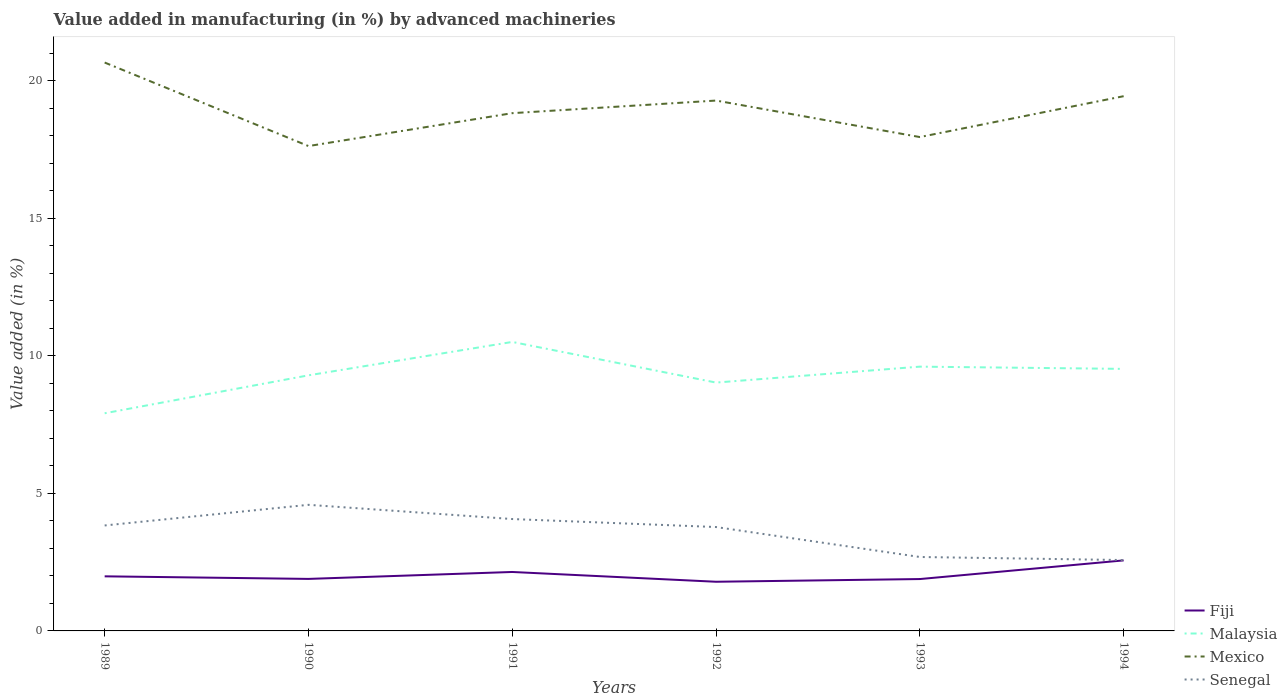Is the number of lines equal to the number of legend labels?
Your response must be concise. Yes. Across all years, what is the maximum percentage of value added in manufacturing by advanced machineries in Senegal?
Provide a succinct answer. 2.58. In which year was the percentage of value added in manufacturing by advanced machineries in Malaysia maximum?
Offer a very short reply. 1989. What is the total percentage of value added in manufacturing by advanced machineries in Senegal in the graph?
Offer a very short reply. 1.2. What is the difference between the highest and the second highest percentage of value added in manufacturing by advanced machineries in Senegal?
Give a very brief answer. 2.01. How many lines are there?
Ensure brevity in your answer.  4. How many years are there in the graph?
Make the answer very short. 6. What is the difference between two consecutive major ticks on the Y-axis?
Provide a short and direct response. 5. Does the graph contain grids?
Make the answer very short. No. Where does the legend appear in the graph?
Ensure brevity in your answer.  Bottom right. What is the title of the graph?
Offer a terse response. Value added in manufacturing (in %) by advanced machineries. Does "St. Vincent and the Grenadines" appear as one of the legend labels in the graph?
Your answer should be very brief. No. What is the label or title of the X-axis?
Keep it short and to the point. Years. What is the label or title of the Y-axis?
Give a very brief answer. Value added (in %). What is the Value added (in %) in Fiji in 1989?
Provide a short and direct response. 1.98. What is the Value added (in %) of Malaysia in 1989?
Provide a short and direct response. 7.91. What is the Value added (in %) of Mexico in 1989?
Your answer should be very brief. 20.66. What is the Value added (in %) in Senegal in 1989?
Your answer should be compact. 3.83. What is the Value added (in %) of Fiji in 1990?
Offer a very short reply. 1.89. What is the Value added (in %) of Malaysia in 1990?
Provide a succinct answer. 9.29. What is the Value added (in %) in Mexico in 1990?
Offer a very short reply. 17.62. What is the Value added (in %) of Senegal in 1990?
Keep it short and to the point. 4.58. What is the Value added (in %) in Fiji in 1991?
Provide a short and direct response. 2.14. What is the Value added (in %) in Malaysia in 1991?
Your response must be concise. 10.5. What is the Value added (in %) of Mexico in 1991?
Your answer should be very brief. 18.82. What is the Value added (in %) of Senegal in 1991?
Offer a terse response. 4.07. What is the Value added (in %) in Fiji in 1992?
Your answer should be compact. 1.79. What is the Value added (in %) in Malaysia in 1992?
Give a very brief answer. 9.03. What is the Value added (in %) of Mexico in 1992?
Offer a very short reply. 19.28. What is the Value added (in %) of Senegal in 1992?
Provide a short and direct response. 3.78. What is the Value added (in %) in Fiji in 1993?
Provide a succinct answer. 1.89. What is the Value added (in %) in Malaysia in 1993?
Ensure brevity in your answer.  9.6. What is the Value added (in %) in Mexico in 1993?
Give a very brief answer. 17.95. What is the Value added (in %) of Senegal in 1993?
Give a very brief answer. 2.69. What is the Value added (in %) in Fiji in 1994?
Provide a short and direct response. 2.56. What is the Value added (in %) in Malaysia in 1994?
Your answer should be very brief. 9.52. What is the Value added (in %) of Mexico in 1994?
Your response must be concise. 19.43. What is the Value added (in %) in Senegal in 1994?
Provide a succinct answer. 2.58. Across all years, what is the maximum Value added (in %) of Fiji?
Offer a terse response. 2.56. Across all years, what is the maximum Value added (in %) in Malaysia?
Offer a very short reply. 10.5. Across all years, what is the maximum Value added (in %) in Mexico?
Provide a short and direct response. 20.66. Across all years, what is the maximum Value added (in %) of Senegal?
Ensure brevity in your answer.  4.58. Across all years, what is the minimum Value added (in %) of Fiji?
Your response must be concise. 1.79. Across all years, what is the minimum Value added (in %) of Malaysia?
Ensure brevity in your answer.  7.91. Across all years, what is the minimum Value added (in %) of Mexico?
Your answer should be very brief. 17.62. Across all years, what is the minimum Value added (in %) in Senegal?
Ensure brevity in your answer.  2.58. What is the total Value added (in %) in Fiji in the graph?
Give a very brief answer. 12.25. What is the total Value added (in %) of Malaysia in the graph?
Give a very brief answer. 55.86. What is the total Value added (in %) of Mexico in the graph?
Offer a terse response. 113.75. What is the total Value added (in %) of Senegal in the graph?
Your answer should be very brief. 21.52. What is the difference between the Value added (in %) of Fiji in 1989 and that in 1990?
Ensure brevity in your answer.  0.09. What is the difference between the Value added (in %) of Malaysia in 1989 and that in 1990?
Offer a very short reply. -1.38. What is the difference between the Value added (in %) of Mexico in 1989 and that in 1990?
Offer a very short reply. 3.04. What is the difference between the Value added (in %) of Senegal in 1989 and that in 1990?
Offer a terse response. -0.75. What is the difference between the Value added (in %) in Fiji in 1989 and that in 1991?
Your response must be concise. -0.16. What is the difference between the Value added (in %) of Malaysia in 1989 and that in 1991?
Offer a very short reply. -2.59. What is the difference between the Value added (in %) in Mexico in 1989 and that in 1991?
Make the answer very short. 1.84. What is the difference between the Value added (in %) in Senegal in 1989 and that in 1991?
Your response must be concise. -0.23. What is the difference between the Value added (in %) of Fiji in 1989 and that in 1992?
Offer a terse response. 0.2. What is the difference between the Value added (in %) in Malaysia in 1989 and that in 1992?
Keep it short and to the point. -1.12. What is the difference between the Value added (in %) in Mexico in 1989 and that in 1992?
Make the answer very short. 1.38. What is the difference between the Value added (in %) of Senegal in 1989 and that in 1992?
Keep it short and to the point. 0.06. What is the difference between the Value added (in %) of Fiji in 1989 and that in 1993?
Make the answer very short. 0.1. What is the difference between the Value added (in %) of Malaysia in 1989 and that in 1993?
Your response must be concise. -1.69. What is the difference between the Value added (in %) of Mexico in 1989 and that in 1993?
Offer a very short reply. 2.71. What is the difference between the Value added (in %) of Senegal in 1989 and that in 1993?
Provide a short and direct response. 1.15. What is the difference between the Value added (in %) of Fiji in 1989 and that in 1994?
Ensure brevity in your answer.  -0.58. What is the difference between the Value added (in %) of Malaysia in 1989 and that in 1994?
Provide a short and direct response. -1.61. What is the difference between the Value added (in %) of Mexico in 1989 and that in 1994?
Provide a short and direct response. 1.22. What is the difference between the Value added (in %) of Senegal in 1989 and that in 1994?
Your answer should be very brief. 1.26. What is the difference between the Value added (in %) of Fiji in 1990 and that in 1991?
Offer a very short reply. -0.25. What is the difference between the Value added (in %) in Malaysia in 1990 and that in 1991?
Make the answer very short. -1.21. What is the difference between the Value added (in %) of Mexico in 1990 and that in 1991?
Your response must be concise. -1.2. What is the difference between the Value added (in %) of Senegal in 1990 and that in 1991?
Ensure brevity in your answer.  0.52. What is the difference between the Value added (in %) of Fiji in 1990 and that in 1992?
Offer a terse response. 0.1. What is the difference between the Value added (in %) of Malaysia in 1990 and that in 1992?
Make the answer very short. 0.26. What is the difference between the Value added (in %) in Mexico in 1990 and that in 1992?
Keep it short and to the point. -1.65. What is the difference between the Value added (in %) in Senegal in 1990 and that in 1992?
Your answer should be very brief. 0.81. What is the difference between the Value added (in %) in Fiji in 1990 and that in 1993?
Make the answer very short. 0.01. What is the difference between the Value added (in %) in Malaysia in 1990 and that in 1993?
Keep it short and to the point. -0.32. What is the difference between the Value added (in %) in Mexico in 1990 and that in 1993?
Your answer should be compact. -0.33. What is the difference between the Value added (in %) in Senegal in 1990 and that in 1993?
Your response must be concise. 1.9. What is the difference between the Value added (in %) of Fiji in 1990 and that in 1994?
Offer a terse response. -0.67. What is the difference between the Value added (in %) of Malaysia in 1990 and that in 1994?
Ensure brevity in your answer.  -0.23. What is the difference between the Value added (in %) of Mexico in 1990 and that in 1994?
Make the answer very short. -1.81. What is the difference between the Value added (in %) of Senegal in 1990 and that in 1994?
Your response must be concise. 2.01. What is the difference between the Value added (in %) in Fiji in 1991 and that in 1992?
Provide a short and direct response. 0.36. What is the difference between the Value added (in %) in Malaysia in 1991 and that in 1992?
Provide a short and direct response. 1.48. What is the difference between the Value added (in %) of Mexico in 1991 and that in 1992?
Your answer should be very brief. -0.46. What is the difference between the Value added (in %) of Senegal in 1991 and that in 1992?
Your answer should be very brief. 0.29. What is the difference between the Value added (in %) in Fiji in 1991 and that in 1993?
Your answer should be compact. 0.26. What is the difference between the Value added (in %) in Malaysia in 1991 and that in 1993?
Your response must be concise. 0.9. What is the difference between the Value added (in %) of Mexico in 1991 and that in 1993?
Provide a short and direct response. 0.87. What is the difference between the Value added (in %) in Senegal in 1991 and that in 1993?
Keep it short and to the point. 1.38. What is the difference between the Value added (in %) in Fiji in 1991 and that in 1994?
Offer a terse response. -0.42. What is the difference between the Value added (in %) of Malaysia in 1991 and that in 1994?
Ensure brevity in your answer.  0.98. What is the difference between the Value added (in %) of Mexico in 1991 and that in 1994?
Make the answer very short. -0.62. What is the difference between the Value added (in %) in Senegal in 1991 and that in 1994?
Keep it short and to the point. 1.49. What is the difference between the Value added (in %) of Fiji in 1992 and that in 1993?
Offer a very short reply. -0.1. What is the difference between the Value added (in %) of Malaysia in 1992 and that in 1993?
Ensure brevity in your answer.  -0.58. What is the difference between the Value added (in %) of Mexico in 1992 and that in 1993?
Give a very brief answer. 1.33. What is the difference between the Value added (in %) of Senegal in 1992 and that in 1993?
Your answer should be very brief. 1.09. What is the difference between the Value added (in %) in Fiji in 1992 and that in 1994?
Offer a terse response. -0.78. What is the difference between the Value added (in %) of Malaysia in 1992 and that in 1994?
Make the answer very short. -0.5. What is the difference between the Value added (in %) of Mexico in 1992 and that in 1994?
Keep it short and to the point. -0.16. What is the difference between the Value added (in %) in Senegal in 1992 and that in 1994?
Your response must be concise. 1.2. What is the difference between the Value added (in %) in Fiji in 1993 and that in 1994?
Ensure brevity in your answer.  -0.68. What is the difference between the Value added (in %) of Malaysia in 1993 and that in 1994?
Your answer should be compact. 0.08. What is the difference between the Value added (in %) in Mexico in 1993 and that in 1994?
Keep it short and to the point. -1.49. What is the difference between the Value added (in %) of Senegal in 1993 and that in 1994?
Give a very brief answer. 0.11. What is the difference between the Value added (in %) in Fiji in 1989 and the Value added (in %) in Malaysia in 1990?
Make the answer very short. -7.3. What is the difference between the Value added (in %) in Fiji in 1989 and the Value added (in %) in Mexico in 1990?
Offer a terse response. -15.64. What is the difference between the Value added (in %) of Fiji in 1989 and the Value added (in %) of Senegal in 1990?
Give a very brief answer. -2.6. What is the difference between the Value added (in %) of Malaysia in 1989 and the Value added (in %) of Mexico in 1990?
Give a very brief answer. -9.71. What is the difference between the Value added (in %) of Malaysia in 1989 and the Value added (in %) of Senegal in 1990?
Give a very brief answer. 3.33. What is the difference between the Value added (in %) of Mexico in 1989 and the Value added (in %) of Senegal in 1990?
Give a very brief answer. 16.07. What is the difference between the Value added (in %) of Fiji in 1989 and the Value added (in %) of Malaysia in 1991?
Your answer should be very brief. -8.52. What is the difference between the Value added (in %) of Fiji in 1989 and the Value added (in %) of Mexico in 1991?
Your answer should be very brief. -16.83. What is the difference between the Value added (in %) in Fiji in 1989 and the Value added (in %) in Senegal in 1991?
Provide a short and direct response. -2.08. What is the difference between the Value added (in %) in Malaysia in 1989 and the Value added (in %) in Mexico in 1991?
Keep it short and to the point. -10.91. What is the difference between the Value added (in %) in Malaysia in 1989 and the Value added (in %) in Senegal in 1991?
Your answer should be compact. 3.84. What is the difference between the Value added (in %) in Mexico in 1989 and the Value added (in %) in Senegal in 1991?
Provide a succinct answer. 16.59. What is the difference between the Value added (in %) in Fiji in 1989 and the Value added (in %) in Malaysia in 1992?
Offer a very short reply. -7.04. What is the difference between the Value added (in %) of Fiji in 1989 and the Value added (in %) of Mexico in 1992?
Your answer should be compact. -17.29. What is the difference between the Value added (in %) of Fiji in 1989 and the Value added (in %) of Senegal in 1992?
Offer a very short reply. -1.79. What is the difference between the Value added (in %) in Malaysia in 1989 and the Value added (in %) in Mexico in 1992?
Your answer should be very brief. -11.36. What is the difference between the Value added (in %) of Malaysia in 1989 and the Value added (in %) of Senegal in 1992?
Your answer should be compact. 4.14. What is the difference between the Value added (in %) of Mexico in 1989 and the Value added (in %) of Senegal in 1992?
Keep it short and to the point. 16.88. What is the difference between the Value added (in %) in Fiji in 1989 and the Value added (in %) in Malaysia in 1993?
Ensure brevity in your answer.  -7.62. What is the difference between the Value added (in %) of Fiji in 1989 and the Value added (in %) of Mexico in 1993?
Provide a short and direct response. -15.96. What is the difference between the Value added (in %) in Fiji in 1989 and the Value added (in %) in Senegal in 1993?
Give a very brief answer. -0.7. What is the difference between the Value added (in %) of Malaysia in 1989 and the Value added (in %) of Mexico in 1993?
Provide a succinct answer. -10.04. What is the difference between the Value added (in %) of Malaysia in 1989 and the Value added (in %) of Senegal in 1993?
Provide a succinct answer. 5.22. What is the difference between the Value added (in %) in Mexico in 1989 and the Value added (in %) in Senegal in 1993?
Offer a very short reply. 17.97. What is the difference between the Value added (in %) in Fiji in 1989 and the Value added (in %) in Malaysia in 1994?
Your response must be concise. -7.54. What is the difference between the Value added (in %) in Fiji in 1989 and the Value added (in %) in Mexico in 1994?
Your answer should be compact. -17.45. What is the difference between the Value added (in %) in Fiji in 1989 and the Value added (in %) in Senegal in 1994?
Provide a short and direct response. -0.59. What is the difference between the Value added (in %) of Malaysia in 1989 and the Value added (in %) of Mexico in 1994?
Keep it short and to the point. -11.52. What is the difference between the Value added (in %) of Malaysia in 1989 and the Value added (in %) of Senegal in 1994?
Keep it short and to the point. 5.33. What is the difference between the Value added (in %) in Mexico in 1989 and the Value added (in %) in Senegal in 1994?
Make the answer very short. 18.08. What is the difference between the Value added (in %) in Fiji in 1990 and the Value added (in %) in Malaysia in 1991?
Provide a short and direct response. -8.61. What is the difference between the Value added (in %) of Fiji in 1990 and the Value added (in %) of Mexico in 1991?
Give a very brief answer. -16.93. What is the difference between the Value added (in %) of Fiji in 1990 and the Value added (in %) of Senegal in 1991?
Your answer should be compact. -2.18. What is the difference between the Value added (in %) in Malaysia in 1990 and the Value added (in %) in Mexico in 1991?
Give a very brief answer. -9.53. What is the difference between the Value added (in %) of Malaysia in 1990 and the Value added (in %) of Senegal in 1991?
Make the answer very short. 5.22. What is the difference between the Value added (in %) of Mexico in 1990 and the Value added (in %) of Senegal in 1991?
Give a very brief answer. 13.56. What is the difference between the Value added (in %) of Fiji in 1990 and the Value added (in %) of Malaysia in 1992?
Give a very brief answer. -7.14. What is the difference between the Value added (in %) of Fiji in 1990 and the Value added (in %) of Mexico in 1992?
Your answer should be very brief. -17.38. What is the difference between the Value added (in %) of Fiji in 1990 and the Value added (in %) of Senegal in 1992?
Offer a terse response. -1.89. What is the difference between the Value added (in %) of Malaysia in 1990 and the Value added (in %) of Mexico in 1992?
Your response must be concise. -9.99. What is the difference between the Value added (in %) in Malaysia in 1990 and the Value added (in %) in Senegal in 1992?
Provide a succinct answer. 5.51. What is the difference between the Value added (in %) in Mexico in 1990 and the Value added (in %) in Senegal in 1992?
Give a very brief answer. 13.85. What is the difference between the Value added (in %) in Fiji in 1990 and the Value added (in %) in Malaysia in 1993?
Offer a very short reply. -7.71. What is the difference between the Value added (in %) in Fiji in 1990 and the Value added (in %) in Mexico in 1993?
Ensure brevity in your answer.  -16.06. What is the difference between the Value added (in %) in Fiji in 1990 and the Value added (in %) in Senegal in 1993?
Ensure brevity in your answer.  -0.8. What is the difference between the Value added (in %) of Malaysia in 1990 and the Value added (in %) of Mexico in 1993?
Offer a very short reply. -8.66. What is the difference between the Value added (in %) in Malaysia in 1990 and the Value added (in %) in Senegal in 1993?
Ensure brevity in your answer.  6.6. What is the difference between the Value added (in %) of Mexico in 1990 and the Value added (in %) of Senegal in 1993?
Provide a succinct answer. 14.93. What is the difference between the Value added (in %) in Fiji in 1990 and the Value added (in %) in Malaysia in 1994?
Provide a succinct answer. -7.63. What is the difference between the Value added (in %) in Fiji in 1990 and the Value added (in %) in Mexico in 1994?
Ensure brevity in your answer.  -17.54. What is the difference between the Value added (in %) in Fiji in 1990 and the Value added (in %) in Senegal in 1994?
Ensure brevity in your answer.  -0.69. What is the difference between the Value added (in %) of Malaysia in 1990 and the Value added (in %) of Mexico in 1994?
Keep it short and to the point. -10.15. What is the difference between the Value added (in %) of Malaysia in 1990 and the Value added (in %) of Senegal in 1994?
Keep it short and to the point. 6.71. What is the difference between the Value added (in %) of Mexico in 1990 and the Value added (in %) of Senegal in 1994?
Give a very brief answer. 15.05. What is the difference between the Value added (in %) in Fiji in 1991 and the Value added (in %) in Malaysia in 1992?
Keep it short and to the point. -6.88. What is the difference between the Value added (in %) in Fiji in 1991 and the Value added (in %) in Mexico in 1992?
Ensure brevity in your answer.  -17.13. What is the difference between the Value added (in %) of Fiji in 1991 and the Value added (in %) of Senegal in 1992?
Make the answer very short. -1.63. What is the difference between the Value added (in %) in Malaysia in 1991 and the Value added (in %) in Mexico in 1992?
Provide a short and direct response. -8.77. What is the difference between the Value added (in %) of Malaysia in 1991 and the Value added (in %) of Senegal in 1992?
Your response must be concise. 6.73. What is the difference between the Value added (in %) of Mexico in 1991 and the Value added (in %) of Senegal in 1992?
Offer a terse response. 15.04. What is the difference between the Value added (in %) in Fiji in 1991 and the Value added (in %) in Malaysia in 1993?
Offer a very short reply. -7.46. What is the difference between the Value added (in %) in Fiji in 1991 and the Value added (in %) in Mexico in 1993?
Your answer should be compact. -15.81. What is the difference between the Value added (in %) in Fiji in 1991 and the Value added (in %) in Senegal in 1993?
Offer a terse response. -0.54. What is the difference between the Value added (in %) in Malaysia in 1991 and the Value added (in %) in Mexico in 1993?
Your answer should be very brief. -7.45. What is the difference between the Value added (in %) in Malaysia in 1991 and the Value added (in %) in Senegal in 1993?
Keep it short and to the point. 7.82. What is the difference between the Value added (in %) of Mexico in 1991 and the Value added (in %) of Senegal in 1993?
Your answer should be compact. 16.13. What is the difference between the Value added (in %) of Fiji in 1991 and the Value added (in %) of Malaysia in 1994?
Your answer should be compact. -7.38. What is the difference between the Value added (in %) in Fiji in 1991 and the Value added (in %) in Mexico in 1994?
Your response must be concise. -17.29. What is the difference between the Value added (in %) of Fiji in 1991 and the Value added (in %) of Senegal in 1994?
Your response must be concise. -0.43. What is the difference between the Value added (in %) in Malaysia in 1991 and the Value added (in %) in Mexico in 1994?
Give a very brief answer. -8.93. What is the difference between the Value added (in %) of Malaysia in 1991 and the Value added (in %) of Senegal in 1994?
Give a very brief answer. 7.93. What is the difference between the Value added (in %) of Mexico in 1991 and the Value added (in %) of Senegal in 1994?
Ensure brevity in your answer.  16.24. What is the difference between the Value added (in %) in Fiji in 1992 and the Value added (in %) in Malaysia in 1993?
Offer a terse response. -7.82. What is the difference between the Value added (in %) of Fiji in 1992 and the Value added (in %) of Mexico in 1993?
Make the answer very short. -16.16. What is the difference between the Value added (in %) of Fiji in 1992 and the Value added (in %) of Senegal in 1993?
Offer a terse response. -0.9. What is the difference between the Value added (in %) of Malaysia in 1992 and the Value added (in %) of Mexico in 1993?
Your answer should be very brief. -8.92. What is the difference between the Value added (in %) in Malaysia in 1992 and the Value added (in %) in Senegal in 1993?
Ensure brevity in your answer.  6.34. What is the difference between the Value added (in %) in Mexico in 1992 and the Value added (in %) in Senegal in 1993?
Make the answer very short. 16.59. What is the difference between the Value added (in %) of Fiji in 1992 and the Value added (in %) of Malaysia in 1994?
Make the answer very short. -7.74. What is the difference between the Value added (in %) in Fiji in 1992 and the Value added (in %) in Mexico in 1994?
Your answer should be compact. -17.65. What is the difference between the Value added (in %) of Fiji in 1992 and the Value added (in %) of Senegal in 1994?
Keep it short and to the point. -0.79. What is the difference between the Value added (in %) in Malaysia in 1992 and the Value added (in %) in Mexico in 1994?
Provide a short and direct response. -10.41. What is the difference between the Value added (in %) of Malaysia in 1992 and the Value added (in %) of Senegal in 1994?
Give a very brief answer. 6.45. What is the difference between the Value added (in %) of Mexico in 1992 and the Value added (in %) of Senegal in 1994?
Provide a short and direct response. 16.7. What is the difference between the Value added (in %) in Fiji in 1993 and the Value added (in %) in Malaysia in 1994?
Provide a short and direct response. -7.64. What is the difference between the Value added (in %) of Fiji in 1993 and the Value added (in %) of Mexico in 1994?
Offer a terse response. -17.55. What is the difference between the Value added (in %) of Fiji in 1993 and the Value added (in %) of Senegal in 1994?
Your response must be concise. -0.69. What is the difference between the Value added (in %) of Malaysia in 1993 and the Value added (in %) of Mexico in 1994?
Offer a very short reply. -9.83. What is the difference between the Value added (in %) of Malaysia in 1993 and the Value added (in %) of Senegal in 1994?
Offer a very short reply. 7.03. What is the difference between the Value added (in %) in Mexico in 1993 and the Value added (in %) in Senegal in 1994?
Offer a very short reply. 15.37. What is the average Value added (in %) in Fiji per year?
Give a very brief answer. 2.04. What is the average Value added (in %) in Malaysia per year?
Give a very brief answer. 9.31. What is the average Value added (in %) of Mexico per year?
Your response must be concise. 18.96. What is the average Value added (in %) of Senegal per year?
Keep it short and to the point. 3.59. In the year 1989, what is the difference between the Value added (in %) in Fiji and Value added (in %) in Malaysia?
Keep it short and to the point. -5.93. In the year 1989, what is the difference between the Value added (in %) of Fiji and Value added (in %) of Mexico?
Your answer should be very brief. -18.67. In the year 1989, what is the difference between the Value added (in %) of Fiji and Value added (in %) of Senegal?
Your answer should be compact. -1.85. In the year 1989, what is the difference between the Value added (in %) of Malaysia and Value added (in %) of Mexico?
Your answer should be compact. -12.75. In the year 1989, what is the difference between the Value added (in %) of Malaysia and Value added (in %) of Senegal?
Offer a terse response. 4.08. In the year 1989, what is the difference between the Value added (in %) in Mexico and Value added (in %) in Senegal?
Offer a terse response. 16.82. In the year 1990, what is the difference between the Value added (in %) in Fiji and Value added (in %) in Malaysia?
Give a very brief answer. -7.4. In the year 1990, what is the difference between the Value added (in %) of Fiji and Value added (in %) of Mexico?
Offer a terse response. -15.73. In the year 1990, what is the difference between the Value added (in %) in Fiji and Value added (in %) in Senegal?
Ensure brevity in your answer.  -2.69. In the year 1990, what is the difference between the Value added (in %) of Malaysia and Value added (in %) of Mexico?
Provide a short and direct response. -8.33. In the year 1990, what is the difference between the Value added (in %) of Malaysia and Value added (in %) of Senegal?
Provide a short and direct response. 4.71. In the year 1990, what is the difference between the Value added (in %) in Mexico and Value added (in %) in Senegal?
Offer a very short reply. 13.04. In the year 1991, what is the difference between the Value added (in %) in Fiji and Value added (in %) in Malaysia?
Offer a very short reply. -8.36. In the year 1991, what is the difference between the Value added (in %) of Fiji and Value added (in %) of Mexico?
Keep it short and to the point. -16.67. In the year 1991, what is the difference between the Value added (in %) in Fiji and Value added (in %) in Senegal?
Provide a short and direct response. -1.92. In the year 1991, what is the difference between the Value added (in %) in Malaysia and Value added (in %) in Mexico?
Offer a very short reply. -8.31. In the year 1991, what is the difference between the Value added (in %) in Malaysia and Value added (in %) in Senegal?
Your answer should be very brief. 6.44. In the year 1991, what is the difference between the Value added (in %) of Mexico and Value added (in %) of Senegal?
Your answer should be very brief. 14.75. In the year 1992, what is the difference between the Value added (in %) of Fiji and Value added (in %) of Malaysia?
Your response must be concise. -7.24. In the year 1992, what is the difference between the Value added (in %) of Fiji and Value added (in %) of Mexico?
Make the answer very short. -17.49. In the year 1992, what is the difference between the Value added (in %) of Fiji and Value added (in %) of Senegal?
Your answer should be very brief. -1.99. In the year 1992, what is the difference between the Value added (in %) in Malaysia and Value added (in %) in Mexico?
Keep it short and to the point. -10.25. In the year 1992, what is the difference between the Value added (in %) in Malaysia and Value added (in %) in Senegal?
Keep it short and to the point. 5.25. In the year 1992, what is the difference between the Value added (in %) in Mexico and Value added (in %) in Senegal?
Make the answer very short. 15.5. In the year 1993, what is the difference between the Value added (in %) in Fiji and Value added (in %) in Malaysia?
Ensure brevity in your answer.  -7.72. In the year 1993, what is the difference between the Value added (in %) in Fiji and Value added (in %) in Mexico?
Ensure brevity in your answer.  -16.06. In the year 1993, what is the difference between the Value added (in %) of Fiji and Value added (in %) of Senegal?
Your response must be concise. -0.8. In the year 1993, what is the difference between the Value added (in %) in Malaysia and Value added (in %) in Mexico?
Your answer should be very brief. -8.34. In the year 1993, what is the difference between the Value added (in %) in Malaysia and Value added (in %) in Senegal?
Your response must be concise. 6.92. In the year 1993, what is the difference between the Value added (in %) of Mexico and Value added (in %) of Senegal?
Provide a short and direct response. 15.26. In the year 1994, what is the difference between the Value added (in %) of Fiji and Value added (in %) of Malaysia?
Your answer should be very brief. -6.96. In the year 1994, what is the difference between the Value added (in %) in Fiji and Value added (in %) in Mexico?
Provide a succinct answer. -16.87. In the year 1994, what is the difference between the Value added (in %) of Fiji and Value added (in %) of Senegal?
Keep it short and to the point. -0.01. In the year 1994, what is the difference between the Value added (in %) of Malaysia and Value added (in %) of Mexico?
Provide a short and direct response. -9.91. In the year 1994, what is the difference between the Value added (in %) in Malaysia and Value added (in %) in Senegal?
Your response must be concise. 6.95. In the year 1994, what is the difference between the Value added (in %) in Mexico and Value added (in %) in Senegal?
Offer a very short reply. 16.86. What is the ratio of the Value added (in %) in Fiji in 1989 to that in 1990?
Your answer should be compact. 1.05. What is the ratio of the Value added (in %) of Malaysia in 1989 to that in 1990?
Ensure brevity in your answer.  0.85. What is the ratio of the Value added (in %) in Mexico in 1989 to that in 1990?
Your response must be concise. 1.17. What is the ratio of the Value added (in %) of Senegal in 1989 to that in 1990?
Provide a succinct answer. 0.84. What is the ratio of the Value added (in %) in Fiji in 1989 to that in 1991?
Make the answer very short. 0.93. What is the ratio of the Value added (in %) in Malaysia in 1989 to that in 1991?
Provide a succinct answer. 0.75. What is the ratio of the Value added (in %) in Mexico in 1989 to that in 1991?
Your answer should be compact. 1.1. What is the ratio of the Value added (in %) in Senegal in 1989 to that in 1991?
Offer a very short reply. 0.94. What is the ratio of the Value added (in %) of Fiji in 1989 to that in 1992?
Provide a short and direct response. 1.11. What is the ratio of the Value added (in %) of Malaysia in 1989 to that in 1992?
Your answer should be compact. 0.88. What is the ratio of the Value added (in %) of Mexico in 1989 to that in 1992?
Make the answer very short. 1.07. What is the ratio of the Value added (in %) in Senegal in 1989 to that in 1992?
Provide a succinct answer. 1.02. What is the ratio of the Value added (in %) of Fiji in 1989 to that in 1993?
Offer a very short reply. 1.05. What is the ratio of the Value added (in %) in Malaysia in 1989 to that in 1993?
Keep it short and to the point. 0.82. What is the ratio of the Value added (in %) in Mexico in 1989 to that in 1993?
Keep it short and to the point. 1.15. What is the ratio of the Value added (in %) of Senegal in 1989 to that in 1993?
Give a very brief answer. 1.43. What is the ratio of the Value added (in %) of Fiji in 1989 to that in 1994?
Give a very brief answer. 0.77. What is the ratio of the Value added (in %) of Malaysia in 1989 to that in 1994?
Your response must be concise. 0.83. What is the ratio of the Value added (in %) of Mexico in 1989 to that in 1994?
Make the answer very short. 1.06. What is the ratio of the Value added (in %) in Senegal in 1989 to that in 1994?
Make the answer very short. 1.49. What is the ratio of the Value added (in %) in Fiji in 1990 to that in 1991?
Offer a terse response. 0.88. What is the ratio of the Value added (in %) of Malaysia in 1990 to that in 1991?
Your answer should be compact. 0.88. What is the ratio of the Value added (in %) in Mexico in 1990 to that in 1991?
Your answer should be compact. 0.94. What is the ratio of the Value added (in %) of Senegal in 1990 to that in 1991?
Provide a short and direct response. 1.13. What is the ratio of the Value added (in %) in Fiji in 1990 to that in 1992?
Your answer should be very brief. 1.06. What is the ratio of the Value added (in %) in Malaysia in 1990 to that in 1992?
Make the answer very short. 1.03. What is the ratio of the Value added (in %) in Mexico in 1990 to that in 1992?
Offer a very short reply. 0.91. What is the ratio of the Value added (in %) in Senegal in 1990 to that in 1992?
Provide a short and direct response. 1.21. What is the ratio of the Value added (in %) of Fiji in 1990 to that in 1993?
Make the answer very short. 1. What is the ratio of the Value added (in %) of Malaysia in 1990 to that in 1993?
Make the answer very short. 0.97. What is the ratio of the Value added (in %) of Mexico in 1990 to that in 1993?
Ensure brevity in your answer.  0.98. What is the ratio of the Value added (in %) in Senegal in 1990 to that in 1993?
Make the answer very short. 1.71. What is the ratio of the Value added (in %) of Fiji in 1990 to that in 1994?
Provide a succinct answer. 0.74. What is the ratio of the Value added (in %) of Malaysia in 1990 to that in 1994?
Your answer should be compact. 0.98. What is the ratio of the Value added (in %) of Mexico in 1990 to that in 1994?
Give a very brief answer. 0.91. What is the ratio of the Value added (in %) of Senegal in 1990 to that in 1994?
Your answer should be very brief. 1.78. What is the ratio of the Value added (in %) in Fiji in 1991 to that in 1992?
Offer a very short reply. 1.2. What is the ratio of the Value added (in %) of Malaysia in 1991 to that in 1992?
Offer a very short reply. 1.16. What is the ratio of the Value added (in %) of Mexico in 1991 to that in 1992?
Your answer should be very brief. 0.98. What is the ratio of the Value added (in %) in Senegal in 1991 to that in 1992?
Provide a short and direct response. 1.08. What is the ratio of the Value added (in %) of Fiji in 1991 to that in 1993?
Offer a very short reply. 1.14. What is the ratio of the Value added (in %) in Malaysia in 1991 to that in 1993?
Provide a succinct answer. 1.09. What is the ratio of the Value added (in %) in Mexico in 1991 to that in 1993?
Keep it short and to the point. 1.05. What is the ratio of the Value added (in %) in Senegal in 1991 to that in 1993?
Your response must be concise. 1.51. What is the ratio of the Value added (in %) in Fiji in 1991 to that in 1994?
Offer a terse response. 0.84. What is the ratio of the Value added (in %) of Malaysia in 1991 to that in 1994?
Provide a succinct answer. 1.1. What is the ratio of the Value added (in %) in Mexico in 1991 to that in 1994?
Provide a succinct answer. 0.97. What is the ratio of the Value added (in %) in Senegal in 1991 to that in 1994?
Make the answer very short. 1.58. What is the ratio of the Value added (in %) of Fiji in 1992 to that in 1993?
Provide a succinct answer. 0.95. What is the ratio of the Value added (in %) of Malaysia in 1992 to that in 1993?
Provide a succinct answer. 0.94. What is the ratio of the Value added (in %) of Mexico in 1992 to that in 1993?
Give a very brief answer. 1.07. What is the ratio of the Value added (in %) in Senegal in 1992 to that in 1993?
Your answer should be compact. 1.41. What is the ratio of the Value added (in %) in Fiji in 1992 to that in 1994?
Your answer should be very brief. 0.7. What is the ratio of the Value added (in %) of Malaysia in 1992 to that in 1994?
Make the answer very short. 0.95. What is the ratio of the Value added (in %) of Mexico in 1992 to that in 1994?
Keep it short and to the point. 0.99. What is the ratio of the Value added (in %) in Senegal in 1992 to that in 1994?
Give a very brief answer. 1.47. What is the ratio of the Value added (in %) in Fiji in 1993 to that in 1994?
Your answer should be compact. 0.74. What is the ratio of the Value added (in %) of Malaysia in 1993 to that in 1994?
Your answer should be very brief. 1.01. What is the ratio of the Value added (in %) in Mexico in 1993 to that in 1994?
Ensure brevity in your answer.  0.92. What is the ratio of the Value added (in %) of Senegal in 1993 to that in 1994?
Give a very brief answer. 1.04. What is the difference between the highest and the second highest Value added (in %) in Fiji?
Provide a succinct answer. 0.42. What is the difference between the highest and the second highest Value added (in %) of Malaysia?
Ensure brevity in your answer.  0.9. What is the difference between the highest and the second highest Value added (in %) in Mexico?
Give a very brief answer. 1.22. What is the difference between the highest and the second highest Value added (in %) of Senegal?
Offer a terse response. 0.52. What is the difference between the highest and the lowest Value added (in %) in Fiji?
Keep it short and to the point. 0.78. What is the difference between the highest and the lowest Value added (in %) of Malaysia?
Provide a short and direct response. 2.59. What is the difference between the highest and the lowest Value added (in %) in Mexico?
Your answer should be very brief. 3.04. What is the difference between the highest and the lowest Value added (in %) in Senegal?
Give a very brief answer. 2.01. 